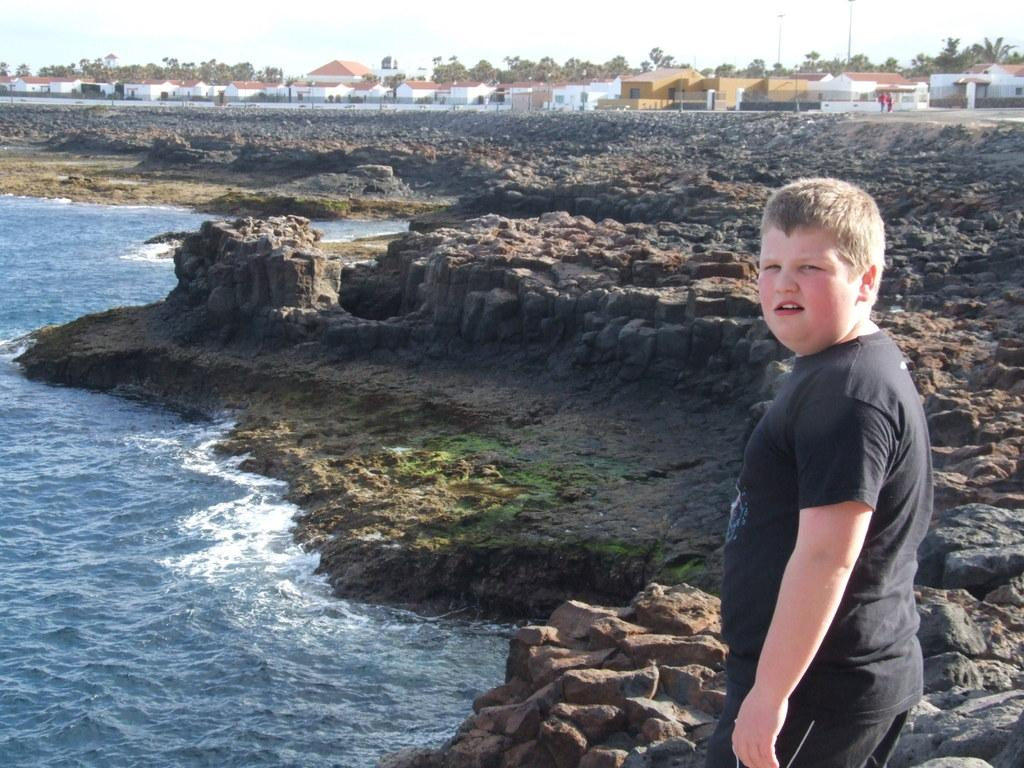What is the main subject of the image? There is a boy standing in the image. What can be seen in the background of the image? The sky is visible in the background of the image. What type of natural elements are present in the image? Water, rocks, and trees are visible in the image. What type of man-made structures are present in the image? Houses and poles are visible in the image. What type of hammer is the laborer using in the image? There is no laborer or hammer present in the image. What type of sidewalk can be seen in the image? There is no sidewalk present in the image. 